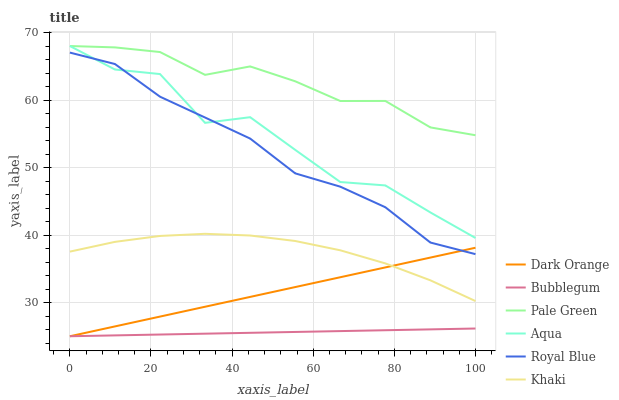Does Bubblegum have the minimum area under the curve?
Answer yes or no. Yes. Does Pale Green have the maximum area under the curve?
Answer yes or no. Yes. Does Khaki have the minimum area under the curve?
Answer yes or no. No. Does Khaki have the maximum area under the curve?
Answer yes or no. No. Is Bubblegum the smoothest?
Answer yes or no. Yes. Is Aqua the roughest?
Answer yes or no. Yes. Is Khaki the smoothest?
Answer yes or no. No. Is Khaki the roughest?
Answer yes or no. No. Does Dark Orange have the lowest value?
Answer yes or no. Yes. Does Khaki have the lowest value?
Answer yes or no. No. Does Pale Green have the highest value?
Answer yes or no. Yes. Does Khaki have the highest value?
Answer yes or no. No. Is Khaki less than Pale Green?
Answer yes or no. Yes. Is Royal Blue greater than Khaki?
Answer yes or no. Yes. Does Aqua intersect Pale Green?
Answer yes or no. Yes. Is Aqua less than Pale Green?
Answer yes or no. No. Is Aqua greater than Pale Green?
Answer yes or no. No. Does Khaki intersect Pale Green?
Answer yes or no. No. 